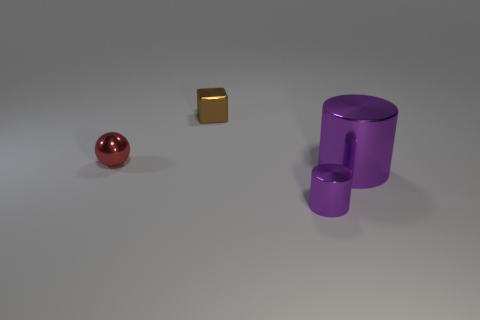Is the color of the big metal cylinder the same as the tiny metal cylinder?
Your answer should be compact. Yes. Is there a big purple metal object of the same shape as the tiny purple shiny object?
Keep it short and to the point. Yes. There is a object that is in front of the large thing; does it have the same color as the big metallic cylinder?
Your answer should be very brief. Yes. There is a thing that is to the left of the brown metallic cube; does it have the same size as the purple metal cylinder behind the tiny purple thing?
Offer a very short reply. No. The brown thing that is the same material as the tiny ball is what size?
Make the answer very short. Small. What number of metallic things are both behind the tiny purple cylinder and in front of the tiny metallic ball?
Provide a short and direct response. 1. How many things are cylinders or small things that are behind the large object?
Make the answer very short. 4. What color is the metal cube that is left of the tiny purple metal object?
Make the answer very short. Brown. How many objects are purple metal objects that are in front of the large metallic cylinder or large cyan balls?
Offer a very short reply. 1. There is a metallic cylinder that is the same size as the metal cube; what color is it?
Offer a terse response. Purple. 